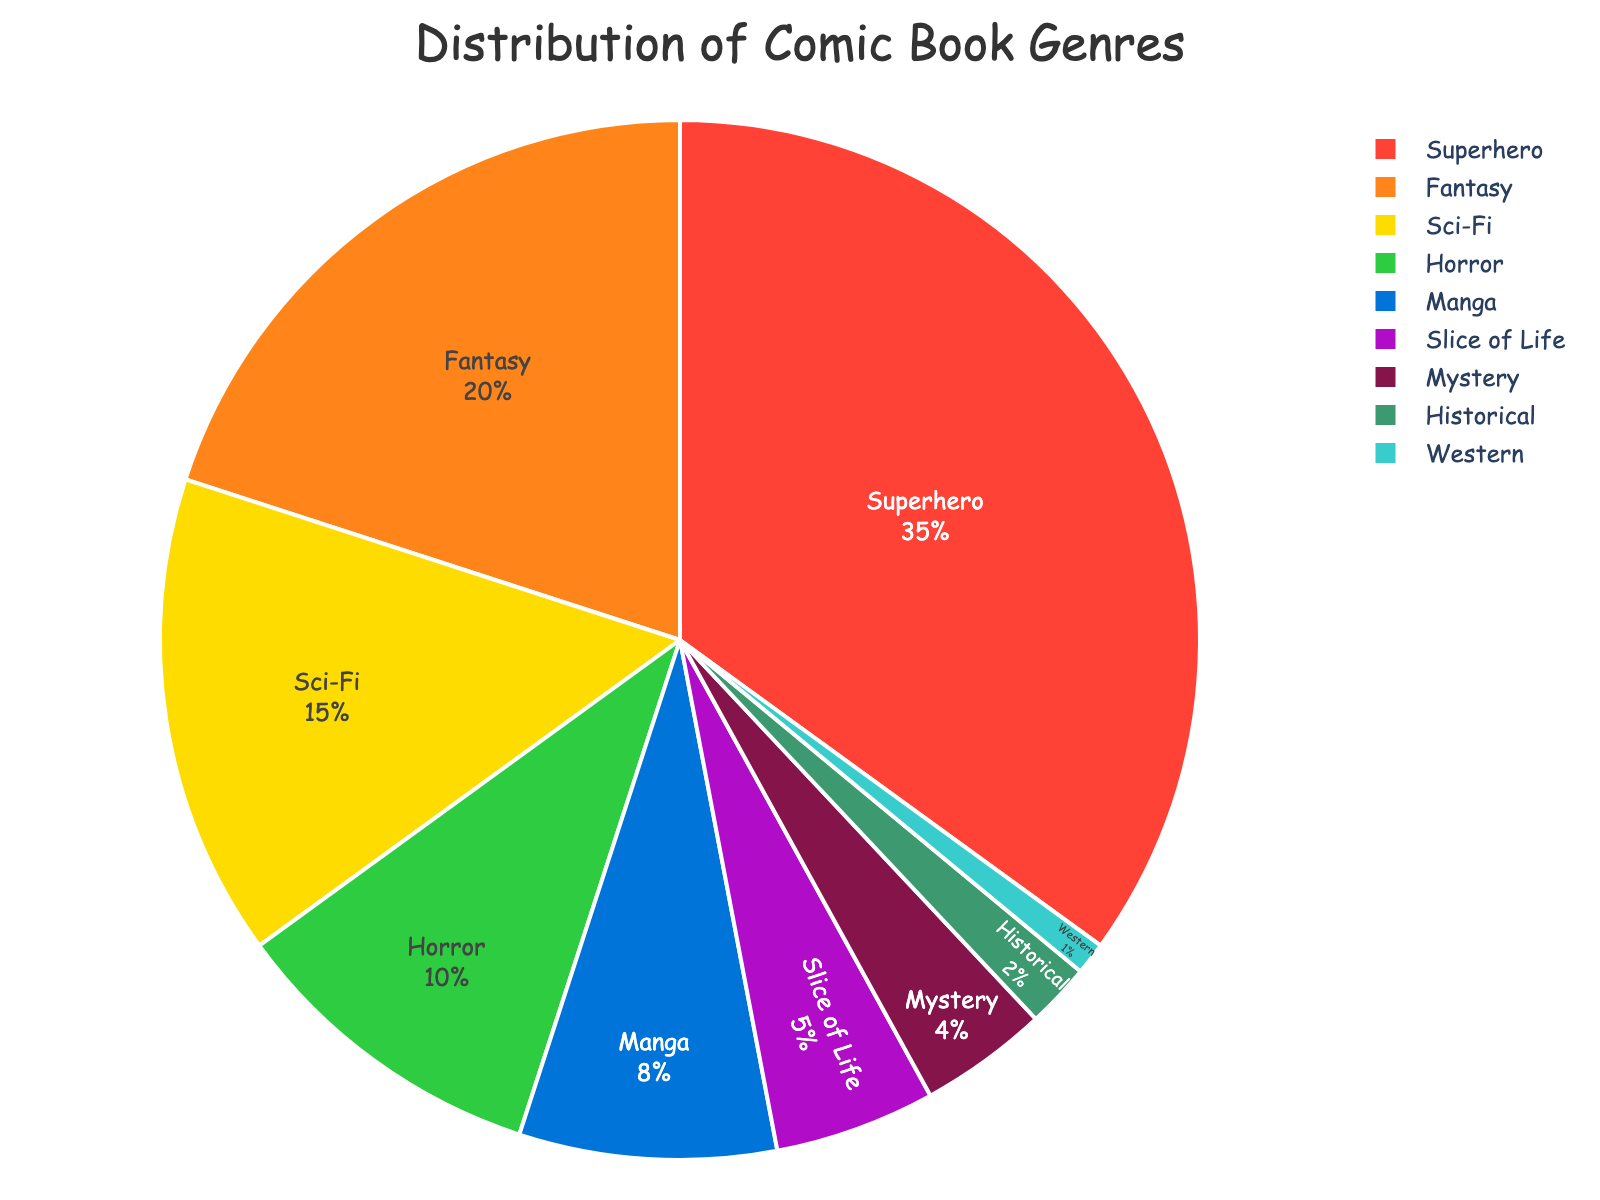What percentage of the comic book collection is made up of Fantasy and Horror genres combined? First, identify the percentages of Fantasy (20%) and Horror (10%) genres. Then, sum these values: 20% + 10% = 30%.
Answer: 30% Which genre has the highest percentage in the comic book collection? The figure shows that Superhero has a slice representing 35%, which is the largest percentage. Thus, the genre with the highest percentage is Superhero.
Answer: Superhero How does the percentage of Sci-Fi compare to Manga? The figure indicates that Sci-Fi has a percentage of 15%, while Manga holds 8%. Therefore, Sci-Fi has a higher percentage than Manga.
Answer: Sci-Fi What color represents the Historical genre in the pie chart? The slice labeled Historical is colored in a distinctive dark shade, matching the green used for this genre in the figure.
Answer: Green What is the total percentage of all genres except for Superhero? Subtract the percentage of Superhero from 100%: 100% - 35% = 65%. The total percentage of all other genres is 65%.
Answer: 65% Which genre has the smallest representation in the comic book collection? The genre with the smallest slice in the pie chart is Western, represented by 1%. Therefore, Western has the smallest representation.
Answer: Western What is the difference in percentage between Fantasy and Mystery genres? The figure shows Fantasy at 20% and Mystery at 4%. Subtract the smaller percentage from the larger one: 20% - 4% = 16%.
Answer: 16% If you combined Manga and Slice of Life, how would their total percentage compare to Sci-Fi? Manga and Slice of Life together make up 8% + 5% = 13%. Sci-Fi is 15%. Therefore, while Sci-Fi (15%) is still greater than this combination (13%), the difference is small.
Answer: Sci-Fi is greater by 2% What two genres collectively make up 30% of the collection? From the pie chart, combining Fantasy (20%) and Horror (10%) results in 30%.
Answer: Fantasy and Horror Which genre is represented by a blue color in the pie chart? The blue slice in the pie chart is labeled as Sci-Fi. Thus, the Sci-Fi genre is represented by blue.
Answer: Sci-Fi 